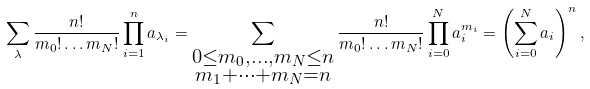<formula> <loc_0><loc_0><loc_500><loc_500>\sum _ { \lambda } \frac { n ! } { m _ { 0 } ! \dots m _ { N } ! } \prod _ { i = 1 } ^ { n } a _ { \lambda _ { i } } = \sum _ { \substack { 0 \leq m _ { 0 } , \dots , m _ { N } \leq n \\ m _ { 1 } + \cdots + m _ { N } = n } } \frac { n ! } { m _ { 0 } ! \dots m _ { N } ! } \prod _ { i = 0 } ^ { N } a _ { i } ^ { m _ { i } } = \left ( \sum _ { i = 0 } ^ { N } a _ { i } \right ) ^ { n } ,</formula> 